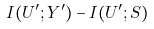<formula> <loc_0><loc_0><loc_500><loc_500>I ( U ^ { \prime } ; Y ^ { \prime } ) - I ( U ^ { \prime } ; S )</formula> 